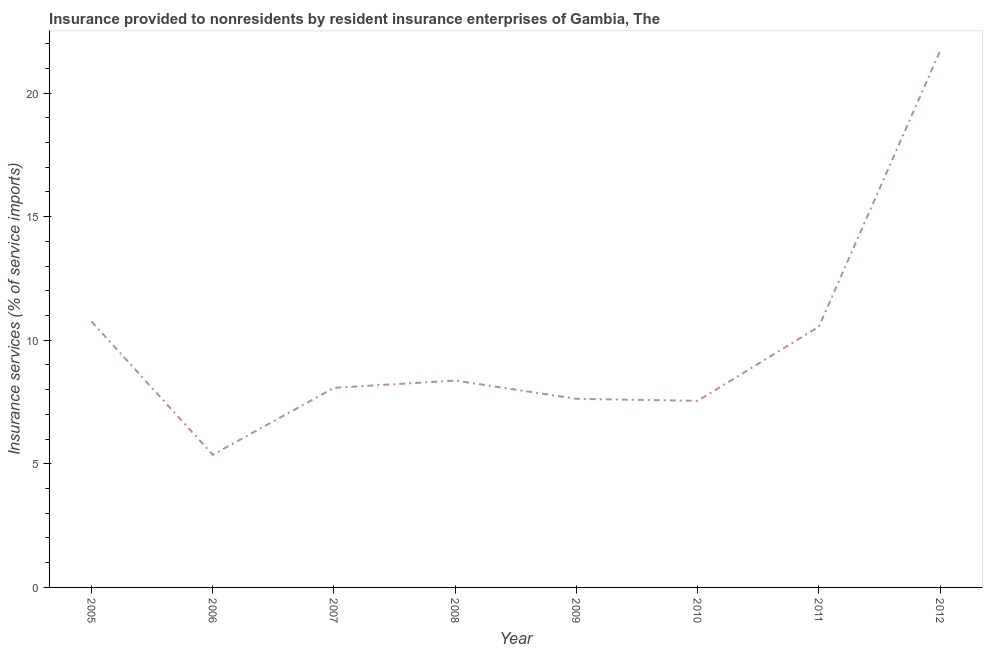What is the insurance and financial services in 2005?
Your answer should be compact. 10.76. Across all years, what is the maximum insurance and financial services?
Keep it short and to the point. 21.7. Across all years, what is the minimum insurance and financial services?
Make the answer very short. 5.37. In which year was the insurance and financial services maximum?
Your answer should be compact. 2012. In which year was the insurance and financial services minimum?
Offer a very short reply. 2006. What is the sum of the insurance and financial services?
Your response must be concise. 80.01. What is the difference between the insurance and financial services in 2007 and 2009?
Make the answer very short. 0.44. What is the average insurance and financial services per year?
Your answer should be compact. 10. What is the median insurance and financial services?
Your answer should be compact. 8.22. What is the ratio of the insurance and financial services in 2005 to that in 2008?
Your answer should be compact. 1.29. What is the difference between the highest and the second highest insurance and financial services?
Your answer should be compact. 10.94. What is the difference between the highest and the lowest insurance and financial services?
Provide a succinct answer. 16.34. Does the insurance and financial services monotonically increase over the years?
Give a very brief answer. No. How many lines are there?
Make the answer very short. 1. What is the difference between two consecutive major ticks on the Y-axis?
Provide a short and direct response. 5. Are the values on the major ticks of Y-axis written in scientific E-notation?
Ensure brevity in your answer.  No. Does the graph contain any zero values?
Your answer should be compact. No. What is the title of the graph?
Ensure brevity in your answer.  Insurance provided to nonresidents by resident insurance enterprises of Gambia, The. What is the label or title of the Y-axis?
Your response must be concise. Insurance services (% of service imports). What is the Insurance services (% of service imports) of 2005?
Provide a succinct answer. 10.76. What is the Insurance services (% of service imports) in 2006?
Provide a short and direct response. 5.37. What is the Insurance services (% of service imports) of 2007?
Provide a short and direct response. 8.08. What is the Insurance services (% of service imports) of 2008?
Keep it short and to the point. 8.37. What is the Insurance services (% of service imports) in 2009?
Make the answer very short. 7.63. What is the Insurance services (% of service imports) in 2010?
Make the answer very short. 7.55. What is the Insurance services (% of service imports) of 2011?
Provide a succinct answer. 10.55. What is the Insurance services (% of service imports) in 2012?
Keep it short and to the point. 21.7. What is the difference between the Insurance services (% of service imports) in 2005 and 2006?
Your answer should be very brief. 5.39. What is the difference between the Insurance services (% of service imports) in 2005 and 2007?
Your response must be concise. 2.68. What is the difference between the Insurance services (% of service imports) in 2005 and 2008?
Your answer should be compact. 2.39. What is the difference between the Insurance services (% of service imports) in 2005 and 2009?
Keep it short and to the point. 3.13. What is the difference between the Insurance services (% of service imports) in 2005 and 2010?
Provide a short and direct response. 3.21. What is the difference between the Insurance services (% of service imports) in 2005 and 2011?
Your response must be concise. 0.21. What is the difference between the Insurance services (% of service imports) in 2005 and 2012?
Keep it short and to the point. -10.94. What is the difference between the Insurance services (% of service imports) in 2006 and 2007?
Give a very brief answer. -2.71. What is the difference between the Insurance services (% of service imports) in 2006 and 2008?
Offer a terse response. -3. What is the difference between the Insurance services (% of service imports) in 2006 and 2009?
Keep it short and to the point. -2.26. What is the difference between the Insurance services (% of service imports) in 2006 and 2010?
Provide a short and direct response. -2.18. What is the difference between the Insurance services (% of service imports) in 2006 and 2011?
Give a very brief answer. -5.18. What is the difference between the Insurance services (% of service imports) in 2006 and 2012?
Offer a terse response. -16.34. What is the difference between the Insurance services (% of service imports) in 2007 and 2008?
Give a very brief answer. -0.29. What is the difference between the Insurance services (% of service imports) in 2007 and 2009?
Ensure brevity in your answer.  0.44. What is the difference between the Insurance services (% of service imports) in 2007 and 2010?
Your response must be concise. 0.53. What is the difference between the Insurance services (% of service imports) in 2007 and 2011?
Provide a short and direct response. -2.48. What is the difference between the Insurance services (% of service imports) in 2007 and 2012?
Your response must be concise. -13.63. What is the difference between the Insurance services (% of service imports) in 2008 and 2009?
Provide a short and direct response. 0.74. What is the difference between the Insurance services (% of service imports) in 2008 and 2010?
Your answer should be compact. 0.82. What is the difference between the Insurance services (% of service imports) in 2008 and 2011?
Ensure brevity in your answer.  -2.18. What is the difference between the Insurance services (% of service imports) in 2008 and 2012?
Ensure brevity in your answer.  -13.33. What is the difference between the Insurance services (% of service imports) in 2009 and 2010?
Ensure brevity in your answer.  0.08. What is the difference between the Insurance services (% of service imports) in 2009 and 2011?
Provide a short and direct response. -2.92. What is the difference between the Insurance services (% of service imports) in 2009 and 2012?
Provide a succinct answer. -14.07. What is the difference between the Insurance services (% of service imports) in 2010 and 2011?
Give a very brief answer. -3. What is the difference between the Insurance services (% of service imports) in 2010 and 2012?
Keep it short and to the point. -14.15. What is the difference between the Insurance services (% of service imports) in 2011 and 2012?
Offer a terse response. -11.15. What is the ratio of the Insurance services (% of service imports) in 2005 to that in 2006?
Keep it short and to the point. 2. What is the ratio of the Insurance services (% of service imports) in 2005 to that in 2007?
Provide a succinct answer. 1.33. What is the ratio of the Insurance services (% of service imports) in 2005 to that in 2008?
Provide a short and direct response. 1.29. What is the ratio of the Insurance services (% of service imports) in 2005 to that in 2009?
Give a very brief answer. 1.41. What is the ratio of the Insurance services (% of service imports) in 2005 to that in 2010?
Give a very brief answer. 1.43. What is the ratio of the Insurance services (% of service imports) in 2005 to that in 2011?
Give a very brief answer. 1.02. What is the ratio of the Insurance services (% of service imports) in 2005 to that in 2012?
Provide a succinct answer. 0.5. What is the ratio of the Insurance services (% of service imports) in 2006 to that in 2007?
Ensure brevity in your answer.  0.67. What is the ratio of the Insurance services (% of service imports) in 2006 to that in 2008?
Make the answer very short. 0.64. What is the ratio of the Insurance services (% of service imports) in 2006 to that in 2009?
Your response must be concise. 0.7. What is the ratio of the Insurance services (% of service imports) in 2006 to that in 2010?
Offer a very short reply. 0.71. What is the ratio of the Insurance services (% of service imports) in 2006 to that in 2011?
Your response must be concise. 0.51. What is the ratio of the Insurance services (% of service imports) in 2006 to that in 2012?
Make the answer very short. 0.25. What is the ratio of the Insurance services (% of service imports) in 2007 to that in 2008?
Keep it short and to the point. 0.96. What is the ratio of the Insurance services (% of service imports) in 2007 to that in 2009?
Offer a very short reply. 1.06. What is the ratio of the Insurance services (% of service imports) in 2007 to that in 2010?
Provide a succinct answer. 1.07. What is the ratio of the Insurance services (% of service imports) in 2007 to that in 2011?
Make the answer very short. 0.77. What is the ratio of the Insurance services (% of service imports) in 2007 to that in 2012?
Provide a short and direct response. 0.37. What is the ratio of the Insurance services (% of service imports) in 2008 to that in 2009?
Offer a very short reply. 1.1. What is the ratio of the Insurance services (% of service imports) in 2008 to that in 2010?
Offer a very short reply. 1.11. What is the ratio of the Insurance services (% of service imports) in 2008 to that in 2011?
Keep it short and to the point. 0.79. What is the ratio of the Insurance services (% of service imports) in 2008 to that in 2012?
Offer a terse response. 0.39. What is the ratio of the Insurance services (% of service imports) in 2009 to that in 2011?
Offer a very short reply. 0.72. What is the ratio of the Insurance services (% of service imports) in 2009 to that in 2012?
Ensure brevity in your answer.  0.35. What is the ratio of the Insurance services (% of service imports) in 2010 to that in 2011?
Offer a very short reply. 0.72. What is the ratio of the Insurance services (% of service imports) in 2010 to that in 2012?
Provide a succinct answer. 0.35. What is the ratio of the Insurance services (% of service imports) in 2011 to that in 2012?
Offer a terse response. 0.49. 